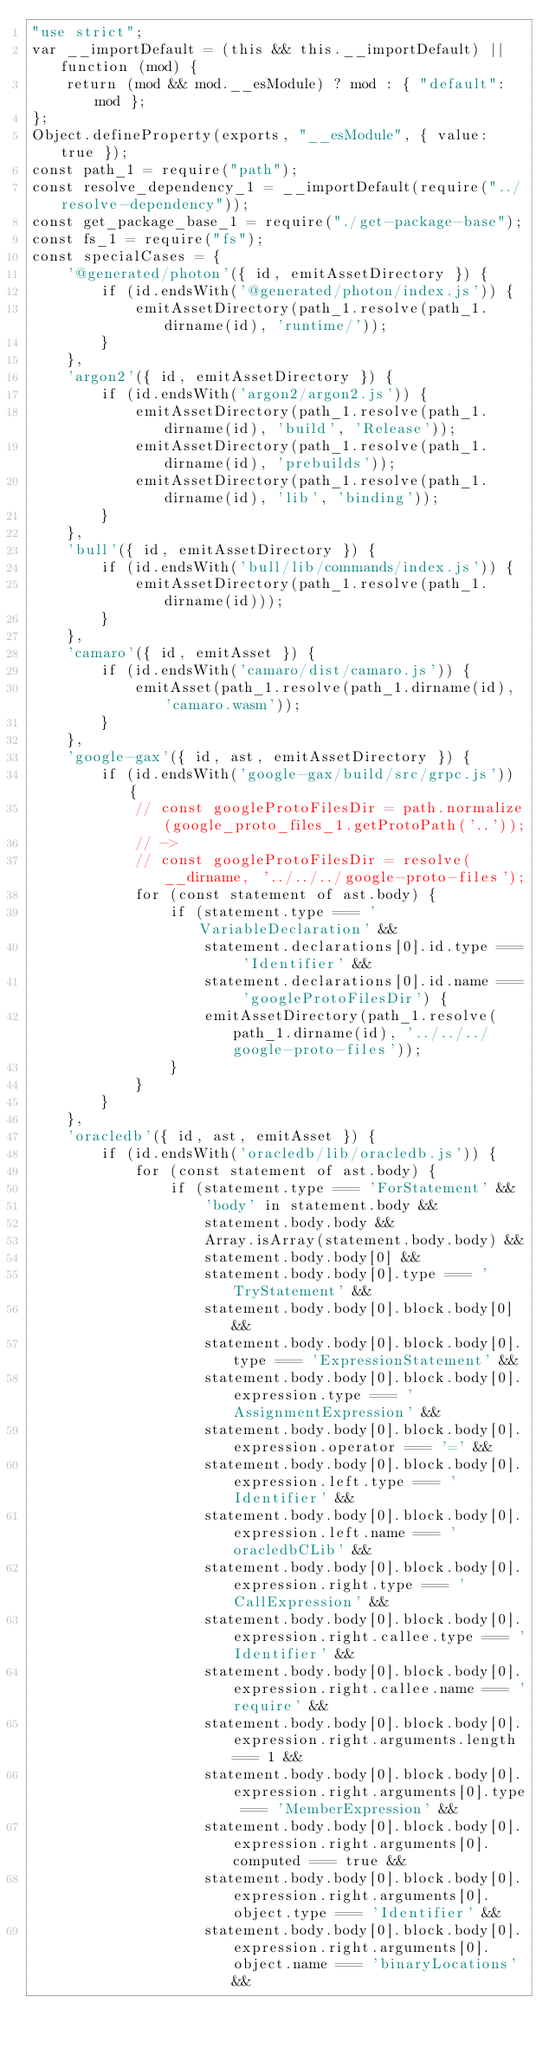Convert code to text. <code><loc_0><loc_0><loc_500><loc_500><_JavaScript_>"use strict";
var __importDefault = (this && this.__importDefault) || function (mod) {
    return (mod && mod.__esModule) ? mod : { "default": mod };
};
Object.defineProperty(exports, "__esModule", { value: true });
const path_1 = require("path");
const resolve_dependency_1 = __importDefault(require("../resolve-dependency"));
const get_package_base_1 = require("./get-package-base");
const fs_1 = require("fs");
const specialCases = {
    '@generated/photon'({ id, emitAssetDirectory }) {
        if (id.endsWith('@generated/photon/index.js')) {
            emitAssetDirectory(path_1.resolve(path_1.dirname(id), 'runtime/'));
        }
    },
    'argon2'({ id, emitAssetDirectory }) {
        if (id.endsWith('argon2/argon2.js')) {
            emitAssetDirectory(path_1.resolve(path_1.dirname(id), 'build', 'Release'));
            emitAssetDirectory(path_1.resolve(path_1.dirname(id), 'prebuilds'));
            emitAssetDirectory(path_1.resolve(path_1.dirname(id), 'lib', 'binding'));
        }
    },
    'bull'({ id, emitAssetDirectory }) {
        if (id.endsWith('bull/lib/commands/index.js')) {
            emitAssetDirectory(path_1.resolve(path_1.dirname(id)));
        }
    },
    'camaro'({ id, emitAsset }) {
        if (id.endsWith('camaro/dist/camaro.js')) {
            emitAsset(path_1.resolve(path_1.dirname(id), 'camaro.wasm'));
        }
    },
    'google-gax'({ id, ast, emitAssetDirectory }) {
        if (id.endsWith('google-gax/build/src/grpc.js')) {
            // const googleProtoFilesDir = path.normalize(google_proto_files_1.getProtoPath('..'));
            // ->
            // const googleProtoFilesDir = resolve(__dirname, '../../../google-proto-files');
            for (const statement of ast.body) {
                if (statement.type === 'VariableDeclaration' &&
                    statement.declarations[0].id.type === 'Identifier' &&
                    statement.declarations[0].id.name === 'googleProtoFilesDir') {
                    emitAssetDirectory(path_1.resolve(path_1.dirname(id), '../../../google-proto-files'));
                }
            }
        }
    },
    'oracledb'({ id, ast, emitAsset }) {
        if (id.endsWith('oracledb/lib/oracledb.js')) {
            for (const statement of ast.body) {
                if (statement.type === 'ForStatement' &&
                    'body' in statement.body &&
                    statement.body.body &&
                    Array.isArray(statement.body.body) &&
                    statement.body.body[0] &&
                    statement.body.body[0].type === 'TryStatement' &&
                    statement.body.body[0].block.body[0] &&
                    statement.body.body[0].block.body[0].type === 'ExpressionStatement' &&
                    statement.body.body[0].block.body[0].expression.type === 'AssignmentExpression' &&
                    statement.body.body[0].block.body[0].expression.operator === '=' &&
                    statement.body.body[0].block.body[0].expression.left.type === 'Identifier' &&
                    statement.body.body[0].block.body[0].expression.left.name === 'oracledbCLib' &&
                    statement.body.body[0].block.body[0].expression.right.type === 'CallExpression' &&
                    statement.body.body[0].block.body[0].expression.right.callee.type === 'Identifier' &&
                    statement.body.body[0].block.body[0].expression.right.callee.name === 'require' &&
                    statement.body.body[0].block.body[0].expression.right.arguments.length === 1 &&
                    statement.body.body[0].block.body[0].expression.right.arguments[0].type === 'MemberExpression' &&
                    statement.body.body[0].block.body[0].expression.right.arguments[0].computed === true &&
                    statement.body.body[0].block.body[0].expression.right.arguments[0].object.type === 'Identifier' &&
                    statement.body.body[0].block.body[0].expression.right.arguments[0].object.name === 'binaryLocations' &&</code> 